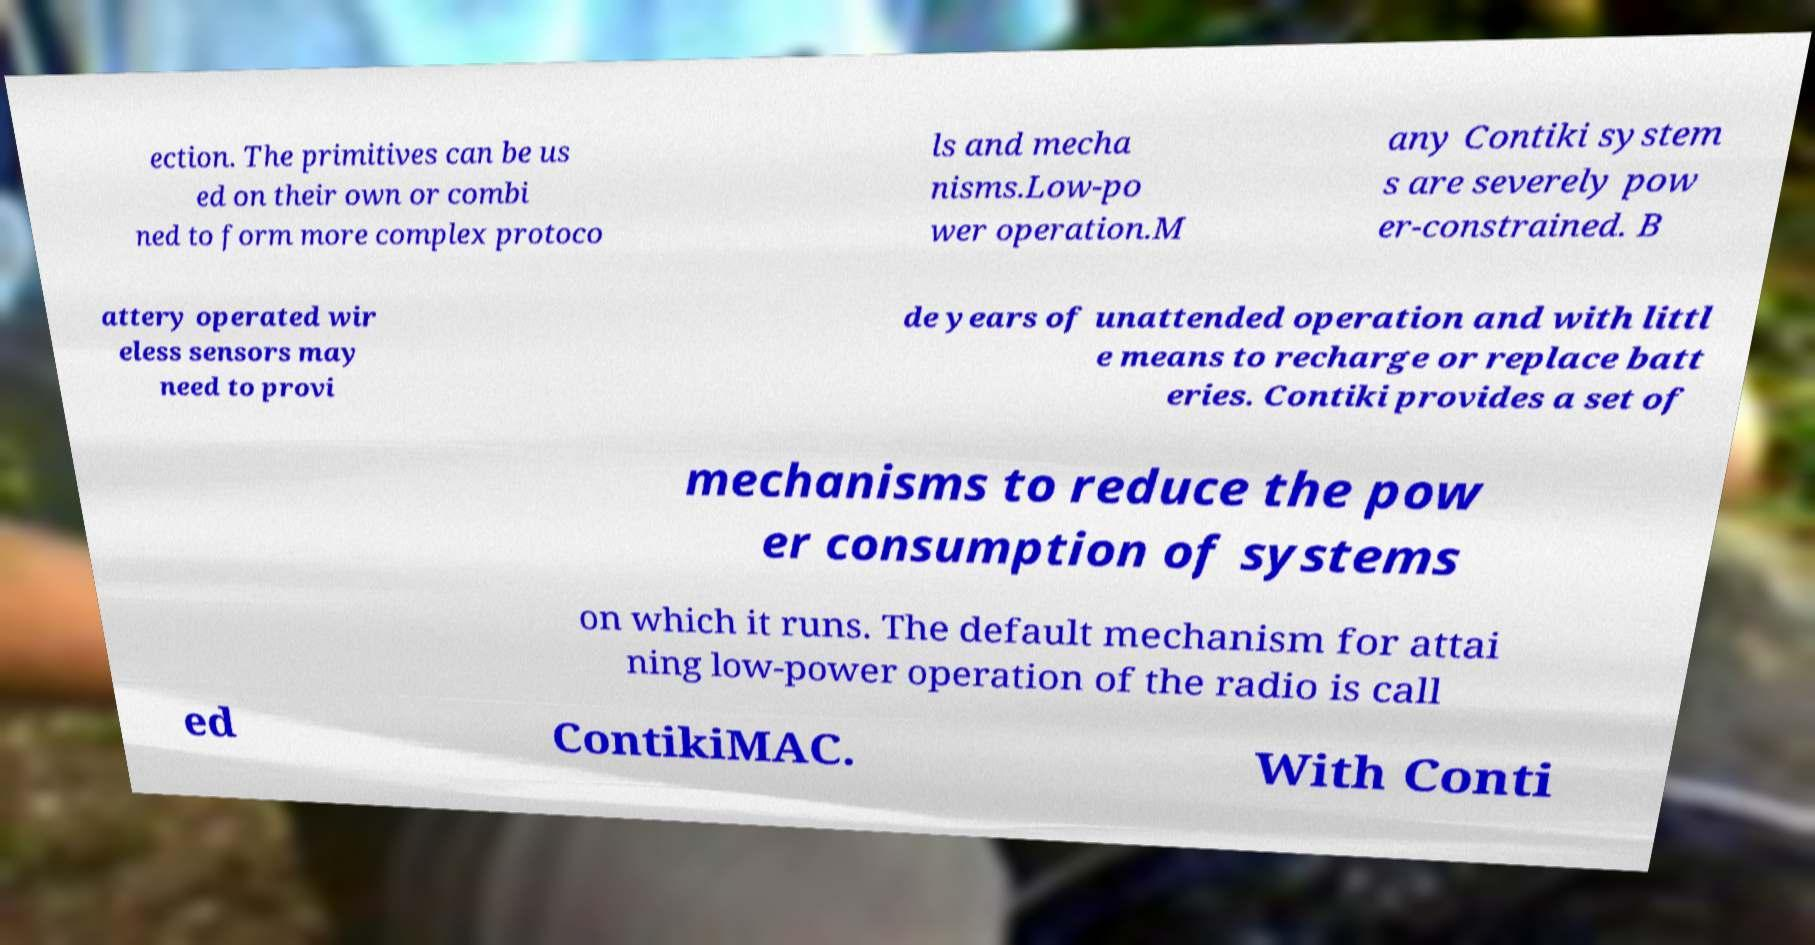For documentation purposes, I need the text within this image transcribed. Could you provide that? ection. The primitives can be us ed on their own or combi ned to form more complex protoco ls and mecha nisms.Low-po wer operation.M any Contiki system s are severely pow er-constrained. B attery operated wir eless sensors may need to provi de years of unattended operation and with littl e means to recharge or replace batt eries. Contiki provides a set of mechanisms to reduce the pow er consumption of systems on which it runs. The default mechanism for attai ning low-power operation of the radio is call ed ContikiMAC. With Conti 